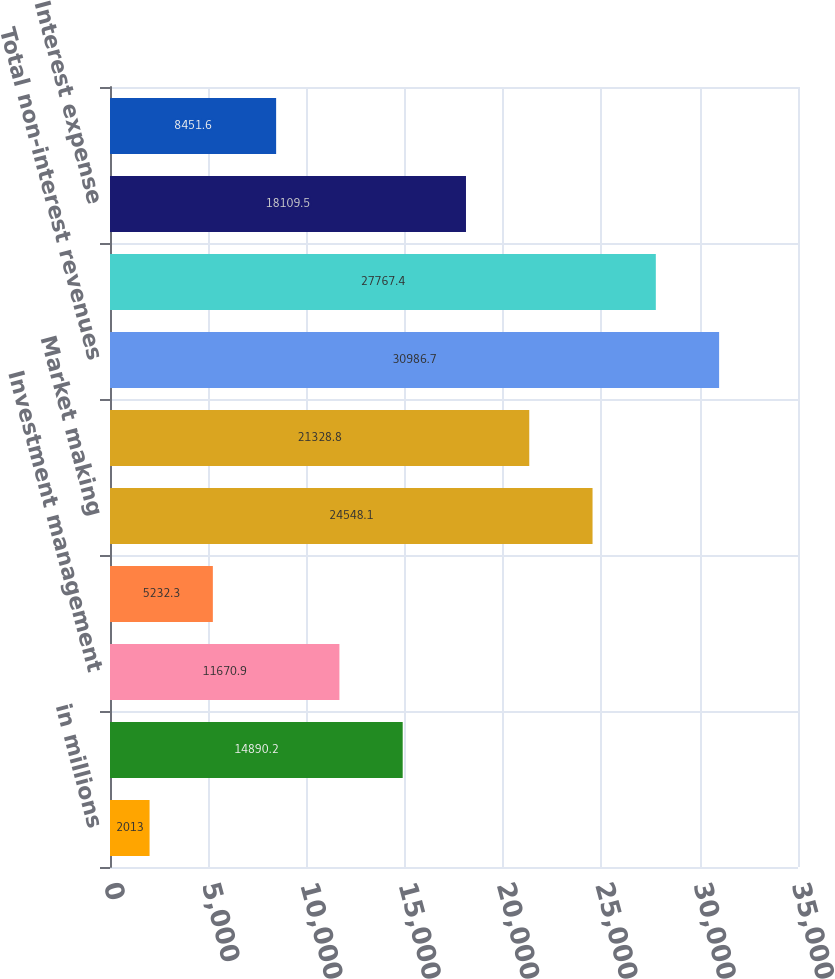Convert chart. <chart><loc_0><loc_0><loc_500><loc_500><bar_chart><fcel>in millions<fcel>Investment banking<fcel>Investment management<fcel>Commissions and fees<fcel>Market making<fcel>Other principal transactions<fcel>Total non-interest revenues<fcel>Interest income<fcel>Interest expense<fcel>Net interest income<nl><fcel>2013<fcel>14890.2<fcel>11670.9<fcel>5232.3<fcel>24548.1<fcel>21328.8<fcel>30986.7<fcel>27767.4<fcel>18109.5<fcel>8451.6<nl></chart> 